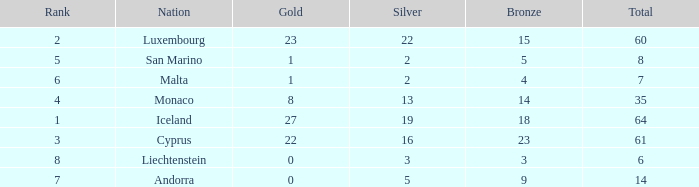Where does Iceland rank with under 19 silvers? None. 